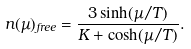Convert formula to latex. <formula><loc_0><loc_0><loc_500><loc_500>n ( \mu ) _ { f r e e } = \frac { 3 \sinh ( \mu / T ) } { K + \cosh ( \mu / T ) } .</formula> 